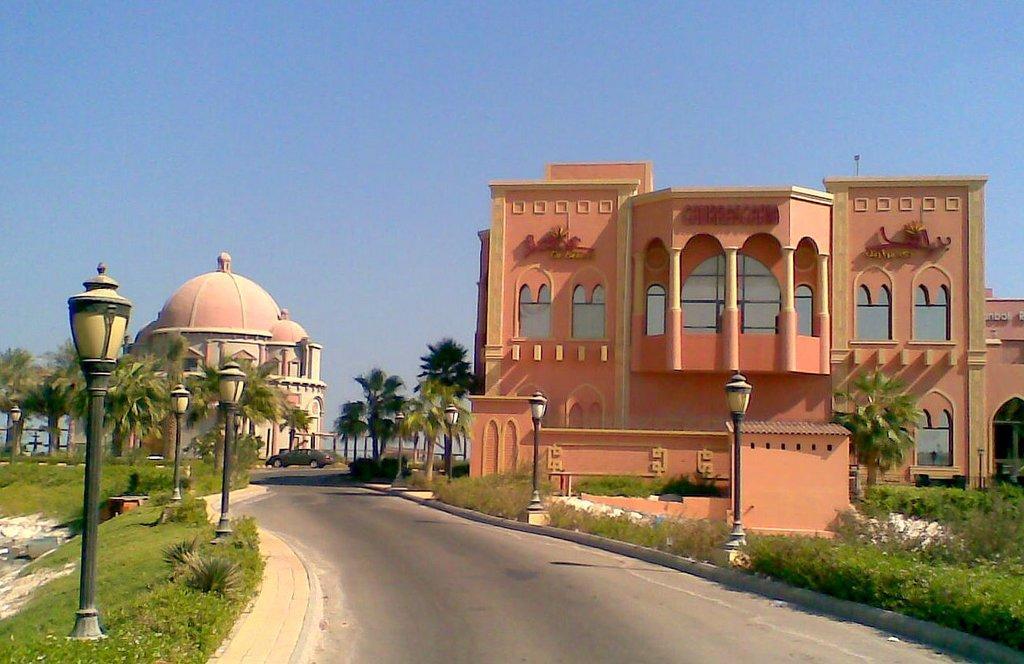Could you give a brief overview of what you see in this image? In the picture there is a plain road and around the road there are pole lights, grass, plants, trees and buildings. In the background there is a vehicle kept in front of one of the building. 